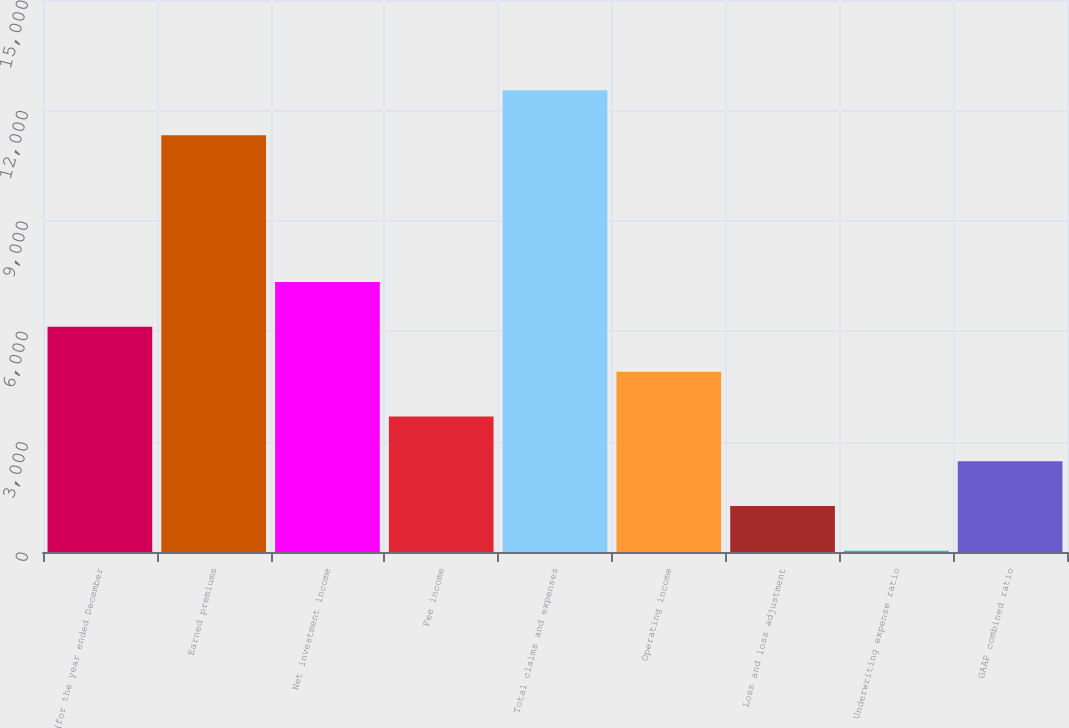Convert chart. <chart><loc_0><loc_0><loc_500><loc_500><bar_chart><fcel>(for the year ended December<fcel>Earned premiums<fcel>Net investment income<fcel>Fee income<fcel>Total claims and expenses<fcel>Operating income<fcel>Loss and loss adjustment<fcel>Underwriting expense ratio<fcel>GAAP combined ratio<nl><fcel>6118.8<fcel>11327<fcel>7336.24<fcel>3683.92<fcel>12544.4<fcel>4901.36<fcel>1249.04<fcel>31.6<fcel>2466.48<nl></chart> 